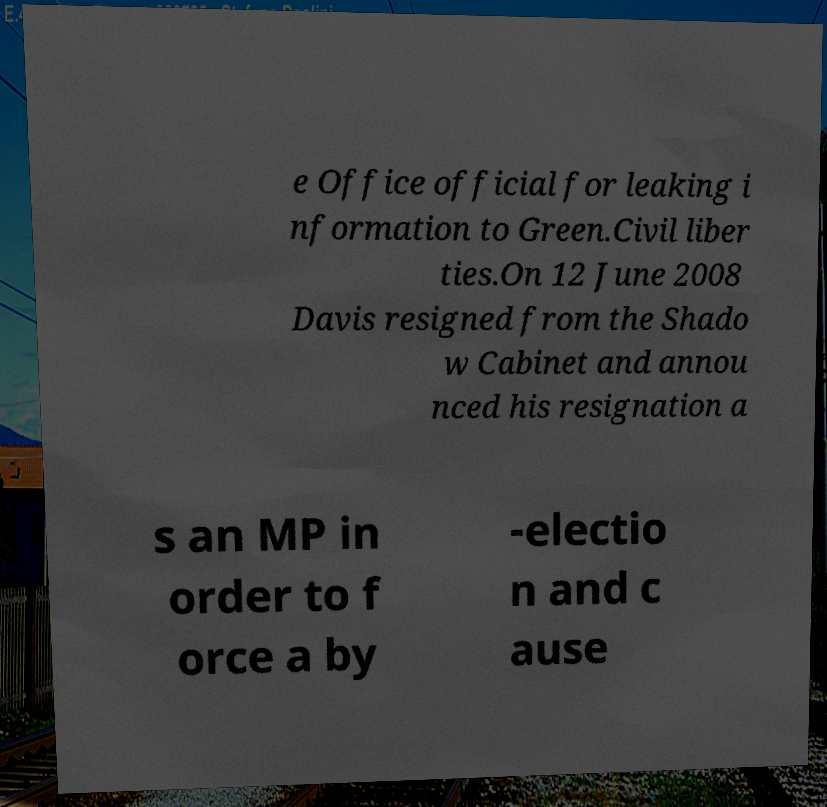There's text embedded in this image that I need extracted. Can you transcribe it verbatim? e Office official for leaking i nformation to Green.Civil liber ties.On 12 June 2008 Davis resigned from the Shado w Cabinet and annou nced his resignation a s an MP in order to f orce a by -electio n and c ause 